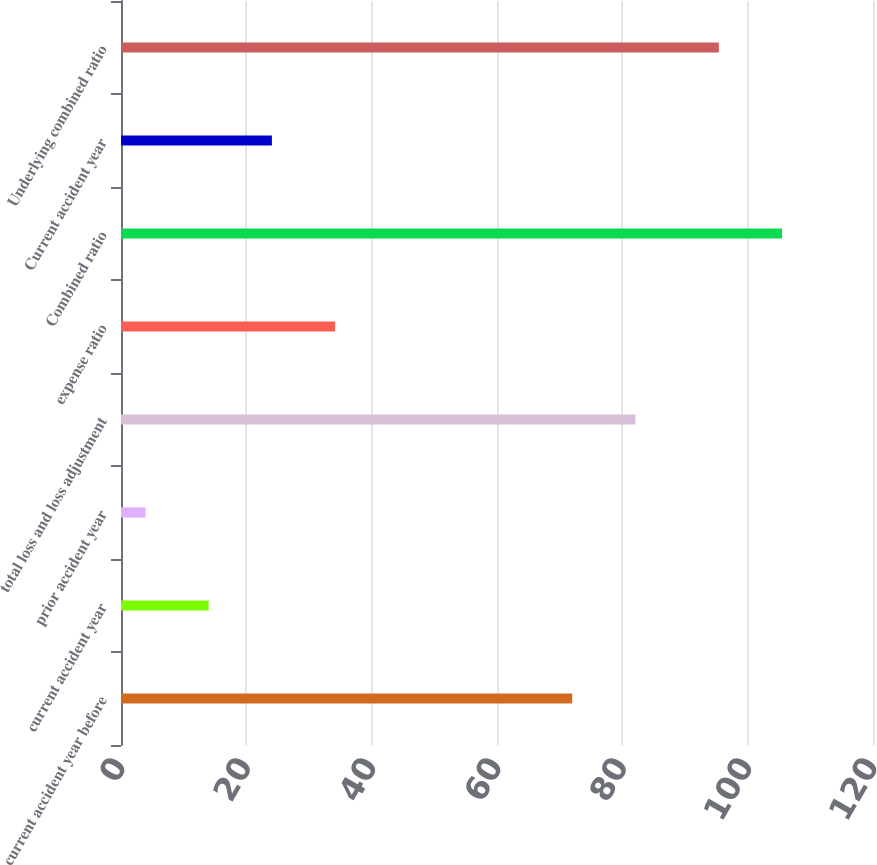Convert chart. <chart><loc_0><loc_0><loc_500><loc_500><bar_chart><fcel>current accident year before<fcel>current accident year<fcel>prior accident year<fcel>total loss and loss adjustment<fcel>expense ratio<fcel>Combined ratio<fcel>Current accident year<fcel>Underlying combined ratio<nl><fcel>72<fcel>13.99<fcel>3.9<fcel>82.09<fcel>34.17<fcel>105.49<fcel>24.08<fcel>95.4<nl></chart> 